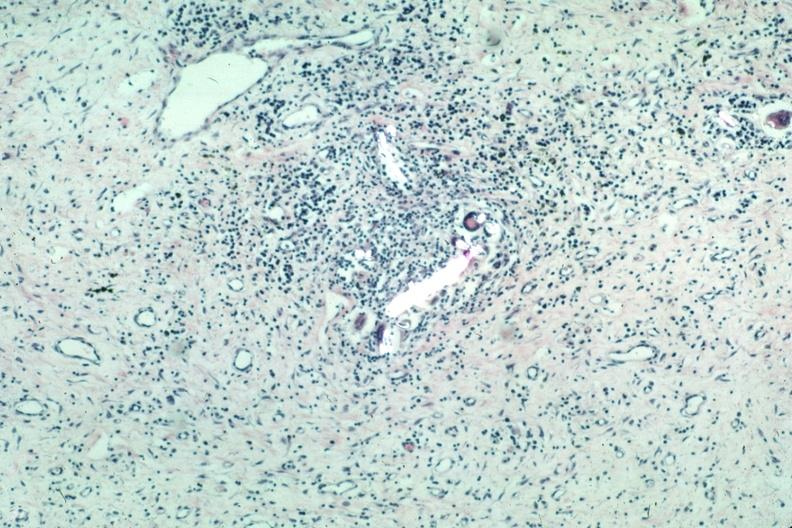s suture granuloma present?
Answer the question using a single word or phrase. Yes 